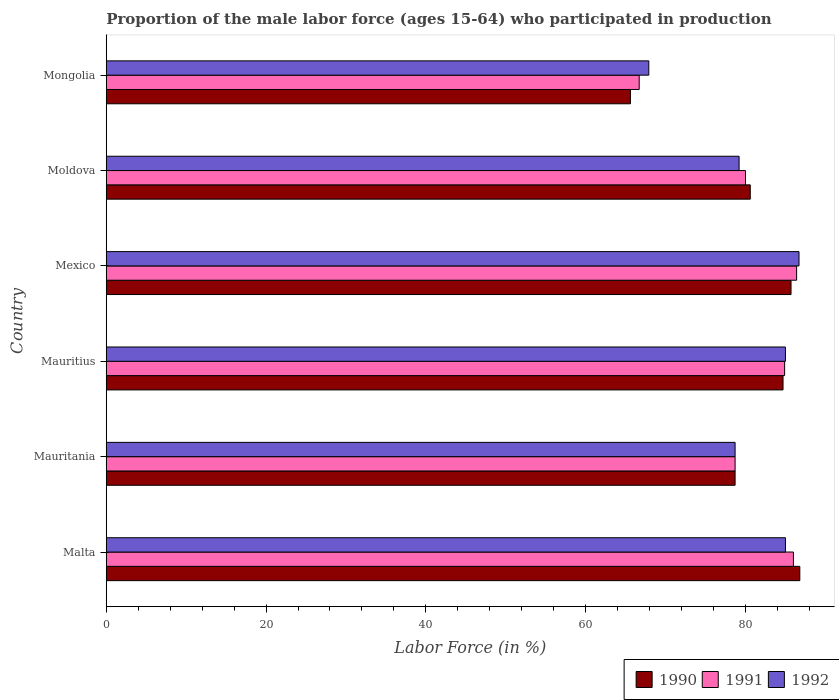How many bars are there on the 4th tick from the bottom?
Ensure brevity in your answer.  3. What is the label of the 1st group of bars from the top?
Provide a short and direct response. Mongolia. In how many cases, is the number of bars for a given country not equal to the number of legend labels?
Ensure brevity in your answer.  0. What is the proportion of the male labor force who participated in production in 1990 in Malta?
Give a very brief answer. 86.8. Across all countries, what is the maximum proportion of the male labor force who participated in production in 1991?
Offer a terse response. 86.4. Across all countries, what is the minimum proportion of the male labor force who participated in production in 1990?
Your answer should be compact. 65.6. In which country was the proportion of the male labor force who participated in production in 1991 minimum?
Provide a succinct answer. Mongolia. What is the total proportion of the male labor force who participated in production in 1992 in the graph?
Ensure brevity in your answer.  482.5. What is the difference between the proportion of the male labor force who participated in production in 1990 in Mauritania and that in Mexico?
Offer a terse response. -7. What is the difference between the proportion of the male labor force who participated in production in 1991 in Mauritius and the proportion of the male labor force who participated in production in 1990 in Mongolia?
Your answer should be very brief. 19.3. What is the average proportion of the male labor force who participated in production in 1992 per country?
Your response must be concise. 80.42. What is the difference between the proportion of the male labor force who participated in production in 1992 and proportion of the male labor force who participated in production in 1990 in Moldova?
Your response must be concise. -1.4. What is the ratio of the proportion of the male labor force who participated in production in 1990 in Mauritania to that in Moldova?
Give a very brief answer. 0.98. What is the difference between the highest and the second highest proportion of the male labor force who participated in production in 1991?
Offer a very short reply. 0.4. What is the difference between the highest and the lowest proportion of the male labor force who participated in production in 1992?
Provide a short and direct response. 18.8. Is it the case that in every country, the sum of the proportion of the male labor force who participated in production in 1992 and proportion of the male labor force who participated in production in 1990 is greater than the proportion of the male labor force who participated in production in 1991?
Your response must be concise. Yes. How many bars are there?
Provide a short and direct response. 18. Are all the bars in the graph horizontal?
Make the answer very short. Yes. What is the difference between two consecutive major ticks on the X-axis?
Offer a very short reply. 20. Are the values on the major ticks of X-axis written in scientific E-notation?
Keep it short and to the point. No. Does the graph contain any zero values?
Your response must be concise. No. Where does the legend appear in the graph?
Provide a succinct answer. Bottom right. How many legend labels are there?
Provide a short and direct response. 3. How are the legend labels stacked?
Your answer should be compact. Horizontal. What is the title of the graph?
Offer a very short reply. Proportion of the male labor force (ages 15-64) who participated in production. What is the label or title of the Y-axis?
Offer a terse response. Country. What is the Labor Force (in %) in 1990 in Malta?
Your response must be concise. 86.8. What is the Labor Force (in %) of 1990 in Mauritania?
Offer a very short reply. 78.7. What is the Labor Force (in %) of 1991 in Mauritania?
Keep it short and to the point. 78.7. What is the Labor Force (in %) of 1992 in Mauritania?
Ensure brevity in your answer.  78.7. What is the Labor Force (in %) of 1990 in Mauritius?
Offer a terse response. 84.7. What is the Labor Force (in %) in 1991 in Mauritius?
Provide a short and direct response. 84.9. What is the Labor Force (in %) of 1990 in Mexico?
Your answer should be very brief. 85.7. What is the Labor Force (in %) in 1991 in Mexico?
Offer a terse response. 86.4. What is the Labor Force (in %) in 1992 in Mexico?
Make the answer very short. 86.7. What is the Labor Force (in %) in 1990 in Moldova?
Provide a succinct answer. 80.6. What is the Labor Force (in %) in 1992 in Moldova?
Your answer should be very brief. 79.2. What is the Labor Force (in %) in 1990 in Mongolia?
Offer a very short reply. 65.6. What is the Labor Force (in %) of 1991 in Mongolia?
Ensure brevity in your answer.  66.7. What is the Labor Force (in %) in 1992 in Mongolia?
Your answer should be very brief. 67.9. Across all countries, what is the maximum Labor Force (in %) of 1990?
Your answer should be compact. 86.8. Across all countries, what is the maximum Labor Force (in %) of 1991?
Give a very brief answer. 86.4. Across all countries, what is the maximum Labor Force (in %) of 1992?
Make the answer very short. 86.7. Across all countries, what is the minimum Labor Force (in %) in 1990?
Make the answer very short. 65.6. Across all countries, what is the minimum Labor Force (in %) of 1991?
Provide a short and direct response. 66.7. Across all countries, what is the minimum Labor Force (in %) of 1992?
Keep it short and to the point. 67.9. What is the total Labor Force (in %) in 1990 in the graph?
Make the answer very short. 482.1. What is the total Labor Force (in %) in 1991 in the graph?
Your answer should be very brief. 482.7. What is the total Labor Force (in %) of 1992 in the graph?
Give a very brief answer. 482.5. What is the difference between the Labor Force (in %) in 1991 in Malta and that in Mauritania?
Provide a succinct answer. 7.3. What is the difference between the Labor Force (in %) in 1992 in Malta and that in Mauritania?
Your response must be concise. 6.3. What is the difference between the Labor Force (in %) in 1990 in Malta and that in Mauritius?
Your response must be concise. 2.1. What is the difference between the Labor Force (in %) in 1991 in Malta and that in Mauritius?
Give a very brief answer. 1.1. What is the difference between the Labor Force (in %) in 1990 in Malta and that in Mexico?
Keep it short and to the point. 1.1. What is the difference between the Labor Force (in %) in 1992 in Malta and that in Mexico?
Provide a short and direct response. -1.7. What is the difference between the Labor Force (in %) in 1991 in Malta and that in Moldova?
Give a very brief answer. 6. What is the difference between the Labor Force (in %) of 1990 in Malta and that in Mongolia?
Ensure brevity in your answer.  21.2. What is the difference between the Labor Force (in %) in 1991 in Malta and that in Mongolia?
Offer a very short reply. 19.3. What is the difference between the Labor Force (in %) in 1992 in Mauritania and that in Mauritius?
Give a very brief answer. -6.3. What is the difference between the Labor Force (in %) of 1990 in Mauritania and that in Mexico?
Make the answer very short. -7. What is the difference between the Labor Force (in %) of 1991 in Mauritania and that in Mexico?
Give a very brief answer. -7.7. What is the difference between the Labor Force (in %) in 1992 in Mauritania and that in Mexico?
Keep it short and to the point. -8. What is the difference between the Labor Force (in %) in 1991 in Mauritania and that in Moldova?
Offer a very short reply. -1.3. What is the difference between the Labor Force (in %) of 1992 in Mauritania and that in Moldova?
Provide a succinct answer. -0.5. What is the difference between the Labor Force (in %) of 1990 in Mauritania and that in Mongolia?
Give a very brief answer. 13.1. What is the difference between the Labor Force (in %) in 1991 in Mauritania and that in Mongolia?
Ensure brevity in your answer.  12. What is the difference between the Labor Force (in %) of 1992 in Mauritania and that in Mongolia?
Make the answer very short. 10.8. What is the difference between the Labor Force (in %) of 1992 in Mauritius and that in Mexico?
Provide a succinct answer. -1.7. What is the difference between the Labor Force (in %) of 1992 in Mauritius and that in Moldova?
Offer a terse response. 5.8. What is the difference between the Labor Force (in %) of 1992 in Mauritius and that in Mongolia?
Your answer should be very brief. 17.1. What is the difference between the Labor Force (in %) in 1992 in Mexico and that in Moldova?
Provide a succinct answer. 7.5. What is the difference between the Labor Force (in %) in 1990 in Mexico and that in Mongolia?
Offer a very short reply. 20.1. What is the difference between the Labor Force (in %) of 1991 in Mexico and that in Mongolia?
Make the answer very short. 19.7. What is the difference between the Labor Force (in %) of 1991 in Moldova and that in Mongolia?
Offer a terse response. 13.3. What is the difference between the Labor Force (in %) in 1991 in Malta and the Labor Force (in %) in 1992 in Mauritania?
Offer a very short reply. 7.3. What is the difference between the Labor Force (in %) of 1991 in Malta and the Labor Force (in %) of 1992 in Mauritius?
Ensure brevity in your answer.  1. What is the difference between the Labor Force (in %) in 1990 in Malta and the Labor Force (in %) in 1991 in Mexico?
Ensure brevity in your answer.  0.4. What is the difference between the Labor Force (in %) in 1991 in Malta and the Labor Force (in %) in 1992 in Mexico?
Your response must be concise. -0.7. What is the difference between the Labor Force (in %) in 1990 in Malta and the Labor Force (in %) in 1991 in Moldova?
Provide a short and direct response. 6.8. What is the difference between the Labor Force (in %) in 1990 in Malta and the Labor Force (in %) in 1992 in Moldova?
Your response must be concise. 7.6. What is the difference between the Labor Force (in %) of 1990 in Malta and the Labor Force (in %) of 1991 in Mongolia?
Keep it short and to the point. 20.1. What is the difference between the Labor Force (in %) in 1991 in Malta and the Labor Force (in %) in 1992 in Mongolia?
Offer a terse response. 18.1. What is the difference between the Labor Force (in %) of 1990 in Mauritania and the Labor Force (in %) of 1991 in Mauritius?
Make the answer very short. -6.2. What is the difference between the Labor Force (in %) in 1990 in Mauritania and the Labor Force (in %) in 1992 in Mauritius?
Your response must be concise. -6.3. What is the difference between the Labor Force (in %) in 1990 in Mauritania and the Labor Force (in %) in 1991 in Moldova?
Your answer should be compact. -1.3. What is the difference between the Labor Force (in %) of 1991 in Mauritania and the Labor Force (in %) of 1992 in Moldova?
Provide a succinct answer. -0.5. What is the difference between the Labor Force (in %) of 1990 in Mauritania and the Labor Force (in %) of 1991 in Mongolia?
Offer a terse response. 12. What is the difference between the Labor Force (in %) in 1990 in Mauritania and the Labor Force (in %) in 1992 in Mongolia?
Make the answer very short. 10.8. What is the difference between the Labor Force (in %) in 1990 in Mauritius and the Labor Force (in %) in 1991 in Mexico?
Provide a succinct answer. -1.7. What is the difference between the Labor Force (in %) in 1990 in Mauritius and the Labor Force (in %) in 1992 in Mexico?
Your answer should be very brief. -2. What is the difference between the Labor Force (in %) in 1991 in Mauritius and the Labor Force (in %) in 1992 in Mexico?
Your answer should be compact. -1.8. What is the difference between the Labor Force (in %) in 1990 in Mauritius and the Labor Force (in %) in 1991 in Moldova?
Ensure brevity in your answer.  4.7. What is the difference between the Labor Force (in %) of 1990 in Mauritius and the Labor Force (in %) of 1992 in Moldova?
Your answer should be very brief. 5.5. What is the difference between the Labor Force (in %) of 1991 in Mauritius and the Labor Force (in %) of 1992 in Moldova?
Your answer should be compact. 5.7. What is the difference between the Labor Force (in %) of 1990 in Mauritius and the Labor Force (in %) of 1991 in Mongolia?
Your answer should be very brief. 18. What is the difference between the Labor Force (in %) in 1990 in Mauritius and the Labor Force (in %) in 1992 in Mongolia?
Ensure brevity in your answer.  16.8. What is the difference between the Labor Force (in %) of 1990 in Mexico and the Labor Force (in %) of 1992 in Moldova?
Your response must be concise. 6.5. What is the difference between the Labor Force (in %) of 1990 in Mexico and the Labor Force (in %) of 1991 in Mongolia?
Your answer should be very brief. 19. What is the difference between the Labor Force (in %) in 1991 in Mexico and the Labor Force (in %) in 1992 in Mongolia?
Keep it short and to the point. 18.5. What is the difference between the Labor Force (in %) in 1990 in Moldova and the Labor Force (in %) in 1991 in Mongolia?
Your answer should be compact. 13.9. What is the average Labor Force (in %) in 1990 per country?
Make the answer very short. 80.35. What is the average Labor Force (in %) in 1991 per country?
Give a very brief answer. 80.45. What is the average Labor Force (in %) in 1992 per country?
Your answer should be compact. 80.42. What is the difference between the Labor Force (in %) in 1990 and Labor Force (in %) in 1991 in Malta?
Give a very brief answer. 0.8. What is the difference between the Labor Force (in %) in 1991 and Labor Force (in %) in 1992 in Malta?
Your response must be concise. 1. What is the difference between the Labor Force (in %) in 1990 and Labor Force (in %) in 1992 in Mauritania?
Provide a short and direct response. 0. What is the difference between the Labor Force (in %) in 1991 and Labor Force (in %) in 1992 in Mauritania?
Provide a succinct answer. 0. What is the difference between the Labor Force (in %) in 1990 and Labor Force (in %) in 1992 in Mauritius?
Provide a succinct answer. -0.3. What is the difference between the Labor Force (in %) in 1990 and Labor Force (in %) in 1992 in Mexico?
Keep it short and to the point. -1. What is the difference between the Labor Force (in %) of 1991 and Labor Force (in %) of 1992 in Mexico?
Ensure brevity in your answer.  -0.3. What is the difference between the Labor Force (in %) of 1990 and Labor Force (in %) of 1992 in Moldova?
Keep it short and to the point. 1.4. What is the difference between the Labor Force (in %) of 1991 and Labor Force (in %) of 1992 in Moldova?
Ensure brevity in your answer.  0.8. What is the difference between the Labor Force (in %) in 1990 and Labor Force (in %) in 1992 in Mongolia?
Ensure brevity in your answer.  -2.3. What is the ratio of the Labor Force (in %) of 1990 in Malta to that in Mauritania?
Ensure brevity in your answer.  1.1. What is the ratio of the Labor Force (in %) in 1991 in Malta to that in Mauritania?
Your answer should be very brief. 1.09. What is the ratio of the Labor Force (in %) in 1992 in Malta to that in Mauritania?
Provide a succinct answer. 1.08. What is the ratio of the Labor Force (in %) of 1990 in Malta to that in Mauritius?
Offer a terse response. 1.02. What is the ratio of the Labor Force (in %) in 1990 in Malta to that in Mexico?
Give a very brief answer. 1.01. What is the ratio of the Labor Force (in %) in 1992 in Malta to that in Mexico?
Your answer should be very brief. 0.98. What is the ratio of the Labor Force (in %) in 1991 in Malta to that in Moldova?
Your answer should be compact. 1.07. What is the ratio of the Labor Force (in %) of 1992 in Malta to that in Moldova?
Keep it short and to the point. 1.07. What is the ratio of the Labor Force (in %) in 1990 in Malta to that in Mongolia?
Provide a short and direct response. 1.32. What is the ratio of the Labor Force (in %) in 1991 in Malta to that in Mongolia?
Make the answer very short. 1.29. What is the ratio of the Labor Force (in %) of 1992 in Malta to that in Mongolia?
Keep it short and to the point. 1.25. What is the ratio of the Labor Force (in %) of 1990 in Mauritania to that in Mauritius?
Offer a very short reply. 0.93. What is the ratio of the Labor Force (in %) of 1991 in Mauritania to that in Mauritius?
Your answer should be compact. 0.93. What is the ratio of the Labor Force (in %) of 1992 in Mauritania to that in Mauritius?
Provide a succinct answer. 0.93. What is the ratio of the Labor Force (in %) in 1990 in Mauritania to that in Mexico?
Keep it short and to the point. 0.92. What is the ratio of the Labor Force (in %) of 1991 in Mauritania to that in Mexico?
Give a very brief answer. 0.91. What is the ratio of the Labor Force (in %) in 1992 in Mauritania to that in Mexico?
Provide a succinct answer. 0.91. What is the ratio of the Labor Force (in %) in 1990 in Mauritania to that in Moldova?
Your answer should be compact. 0.98. What is the ratio of the Labor Force (in %) of 1991 in Mauritania to that in Moldova?
Your answer should be very brief. 0.98. What is the ratio of the Labor Force (in %) in 1990 in Mauritania to that in Mongolia?
Your answer should be very brief. 1.2. What is the ratio of the Labor Force (in %) in 1991 in Mauritania to that in Mongolia?
Offer a terse response. 1.18. What is the ratio of the Labor Force (in %) in 1992 in Mauritania to that in Mongolia?
Ensure brevity in your answer.  1.16. What is the ratio of the Labor Force (in %) of 1990 in Mauritius to that in Mexico?
Offer a terse response. 0.99. What is the ratio of the Labor Force (in %) of 1991 in Mauritius to that in Mexico?
Offer a terse response. 0.98. What is the ratio of the Labor Force (in %) in 1992 in Mauritius to that in Mexico?
Your answer should be compact. 0.98. What is the ratio of the Labor Force (in %) of 1990 in Mauritius to that in Moldova?
Your answer should be compact. 1.05. What is the ratio of the Labor Force (in %) of 1991 in Mauritius to that in Moldova?
Make the answer very short. 1.06. What is the ratio of the Labor Force (in %) of 1992 in Mauritius to that in Moldova?
Your answer should be very brief. 1.07. What is the ratio of the Labor Force (in %) of 1990 in Mauritius to that in Mongolia?
Keep it short and to the point. 1.29. What is the ratio of the Labor Force (in %) of 1991 in Mauritius to that in Mongolia?
Your answer should be very brief. 1.27. What is the ratio of the Labor Force (in %) in 1992 in Mauritius to that in Mongolia?
Your answer should be very brief. 1.25. What is the ratio of the Labor Force (in %) in 1990 in Mexico to that in Moldova?
Offer a terse response. 1.06. What is the ratio of the Labor Force (in %) in 1991 in Mexico to that in Moldova?
Provide a short and direct response. 1.08. What is the ratio of the Labor Force (in %) in 1992 in Mexico to that in Moldova?
Your answer should be very brief. 1.09. What is the ratio of the Labor Force (in %) in 1990 in Mexico to that in Mongolia?
Your answer should be very brief. 1.31. What is the ratio of the Labor Force (in %) in 1991 in Mexico to that in Mongolia?
Give a very brief answer. 1.3. What is the ratio of the Labor Force (in %) of 1992 in Mexico to that in Mongolia?
Your answer should be very brief. 1.28. What is the ratio of the Labor Force (in %) of 1990 in Moldova to that in Mongolia?
Your answer should be compact. 1.23. What is the ratio of the Labor Force (in %) of 1991 in Moldova to that in Mongolia?
Your answer should be compact. 1.2. What is the ratio of the Labor Force (in %) of 1992 in Moldova to that in Mongolia?
Make the answer very short. 1.17. What is the difference between the highest and the lowest Labor Force (in %) in 1990?
Give a very brief answer. 21.2. What is the difference between the highest and the lowest Labor Force (in %) in 1991?
Offer a terse response. 19.7. 